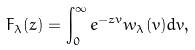<formula> <loc_0><loc_0><loc_500><loc_500>F _ { \lambda } ( z ) = \int _ { 0 } ^ { \infty } e ^ { - z v } w _ { \lambda } ( v ) d v \/ ,</formula> 